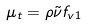Convert formula to latex. <formula><loc_0><loc_0><loc_500><loc_500>\mu _ { t } = \rho \tilde { \nu } f _ { v 1 }</formula> 